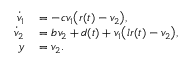<formula> <loc_0><loc_0><loc_500><loc_500>\begin{array} { r l } { \dot { v } _ { 1 } } & = - c v _ { 1 } \left ( r ( t ) - v _ { 2 } \right ) , } \\ { \dot { v } _ { 2 } } & = b v _ { 2 } + d ( t ) + v _ { 1 } \left ( l r ( t ) - v _ { 2 } \right ) , } \\ { y } & = v _ { 2 } . } \end{array}</formula> 